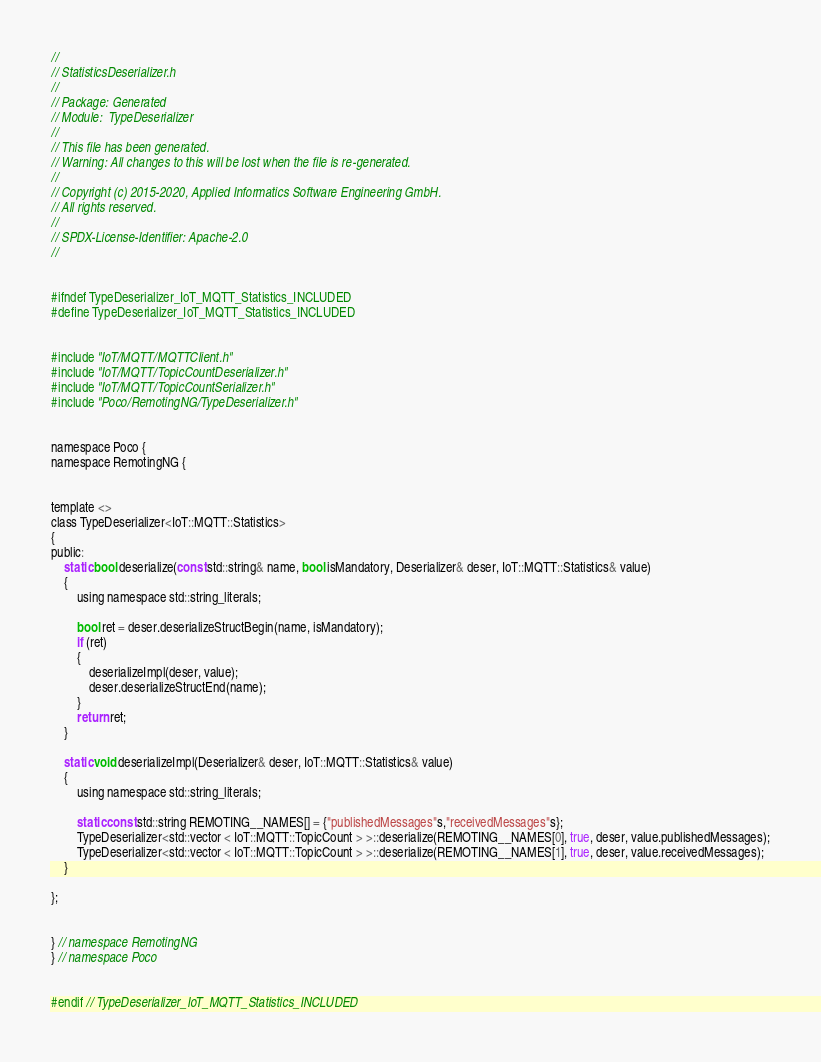<code> <loc_0><loc_0><loc_500><loc_500><_C_>//
// StatisticsDeserializer.h
//
// Package: Generated
// Module:  TypeDeserializer
//
// This file has been generated.
// Warning: All changes to this will be lost when the file is re-generated.
//
// Copyright (c) 2015-2020, Applied Informatics Software Engineering GmbH.
// All rights reserved.
// 
// SPDX-License-Identifier: Apache-2.0
//


#ifndef TypeDeserializer_IoT_MQTT_Statistics_INCLUDED
#define TypeDeserializer_IoT_MQTT_Statistics_INCLUDED


#include "IoT/MQTT/MQTTClient.h"
#include "IoT/MQTT/TopicCountDeserializer.h"
#include "IoT/MQTT/TopicCountSerializer.h"
#include "Poco/RemotingNG/TypeDeserializer.h"


namespace Poco {
namespace RemotingNG {


template <>
class TypeDeserializer<IoT::MQTT::Statistics>
{
public:
	static bool deserialize(const std::string& name, bool isMandatory, Deserializer& deser, IoT::MQTT::Statistics& value)
	{
		using namespace std::string_literals;
		
		bool ret = deser.deserializeStructBegin(name, isMandatory);
		if (ret)
		{
			deserializeImpl(deser, value);
			deser.deserializeStructEnd(name);
		}
		return ret;
	}

	static void deserializeImpl(Deserializer& deser, IoT::MQTT::Statistics& value)
	{
		using namespace std::string_literals;
		
		static const std::string REMOTING__NAMES[] = {"publishedMessages"s,"receivedMessages"s};
		TypeDeserializer<std::vector < IoT::MQTT::TopicCount > >::deserialize(REMOTING__NAMES[0], true, deser, value.publishedMessages);
		TypeDeserializer<std::vector < IoT::MQTT::TopicCount > >::deserialize(REMOTING__NAMES[1], true, deser, value.receivedMessages);
	}

};


} // namespace RemotingNG
} // namespace Poco


#endif // TypeDeserializer_IoT_MQTT_Statistics_INCLUDED

</code> 